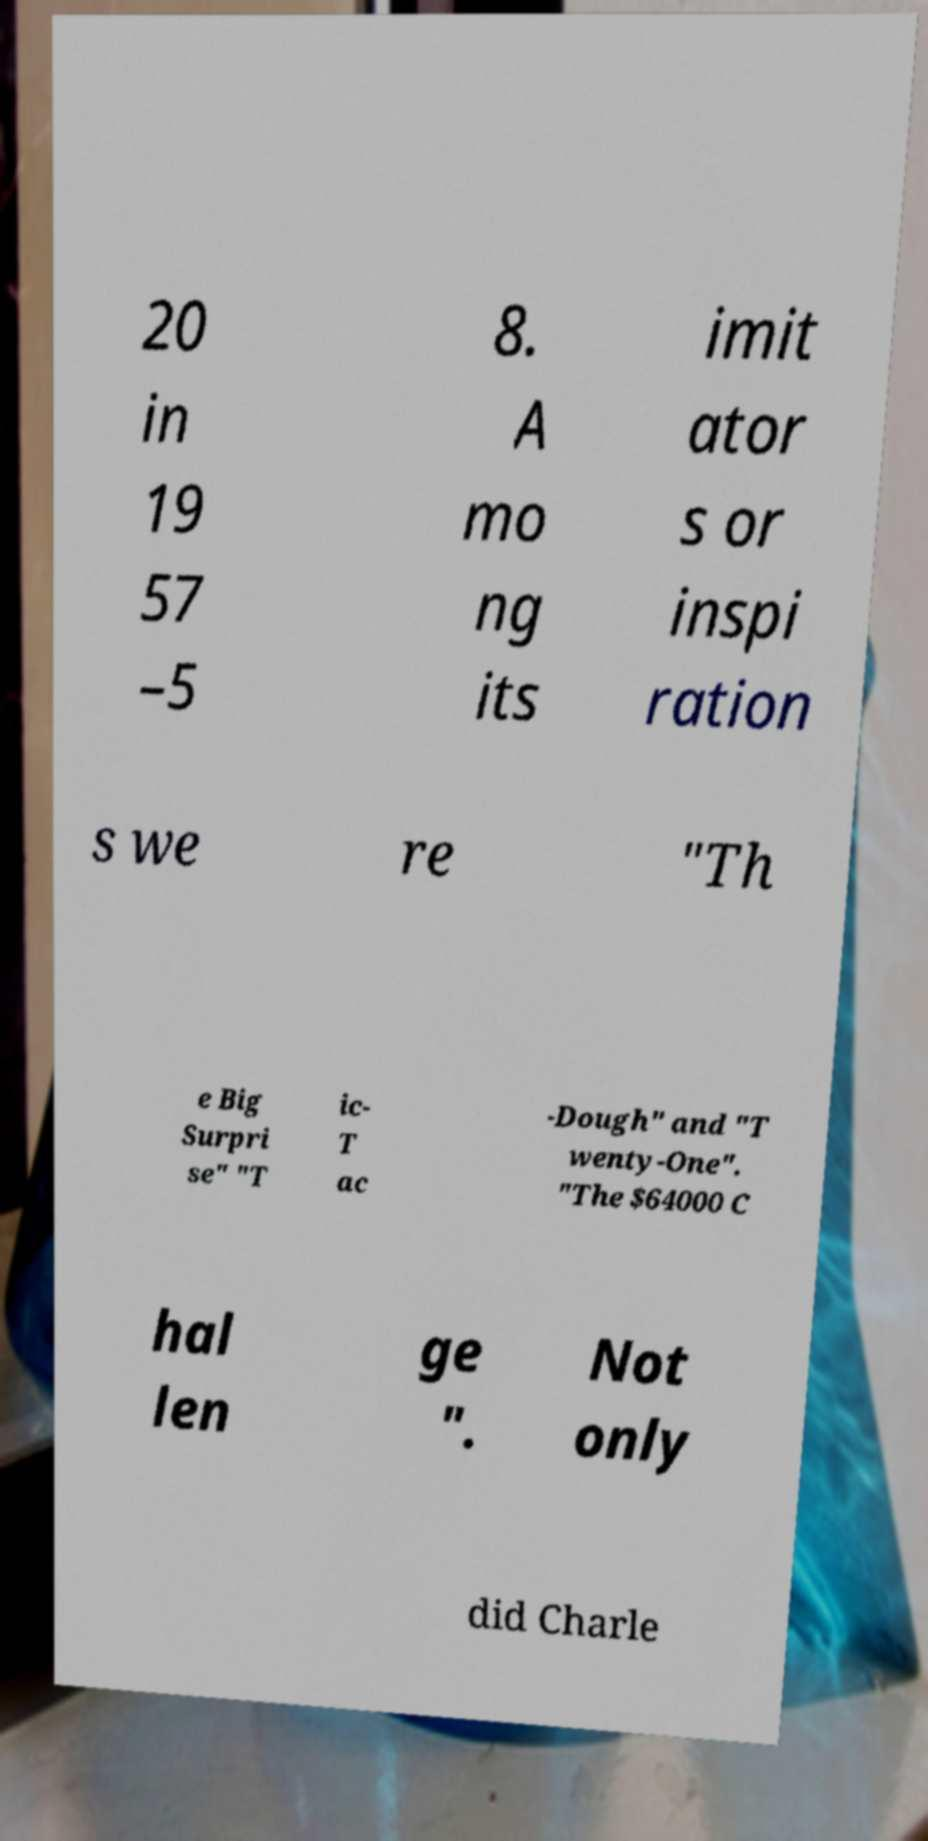Could you extract and type out the text from this image? 20 in 19 57 –5 8. A mo ng its imit ator s or inspi ration s we re "Th e Big Surpri se" "T ic- T ac -Dough" and "T wenty-One". "The $64000 C hal len ge ". Not only did Charle 